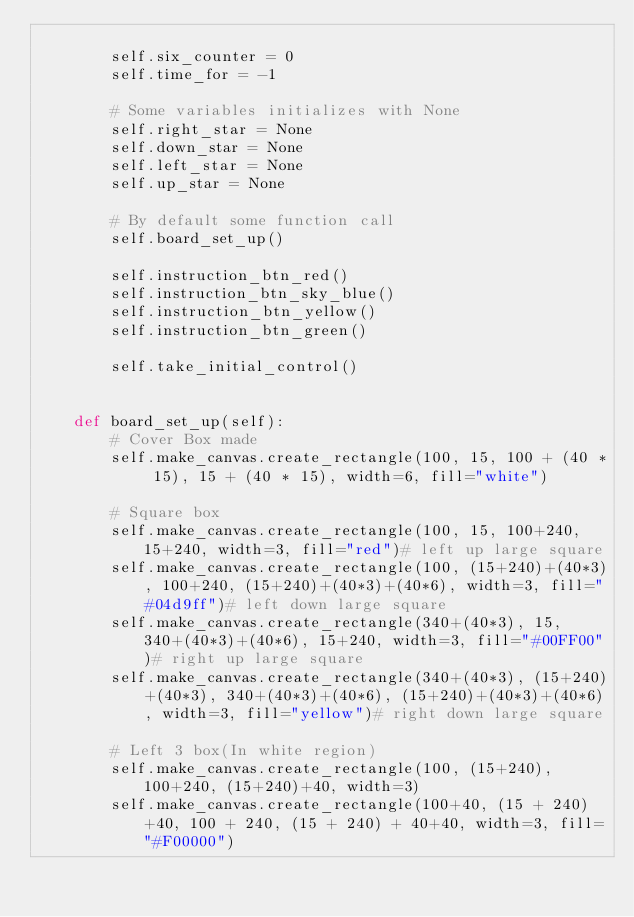Convert code to text. <code><loc_0><loc_0><loc_500><loc_500><_Python_>
        self.six_counter = 0
        self.time_for = -1

        # Some variables initializes with None
        self.right_star = None
        self.down_star = None
        self.left_star = None
        self.up_star = None

        # By default some function call
        self.board_set_up()

        self.instruction_btn_red()
        self.instruction_btn_sky_blue()
        self.instruction_btn_yellow()
        self.instruction_btn_green()

        self.take_initial_control()


    def board_set_up(self):
        # Cover Box made
        self.make_canvas.create_rectangle(100, 15, 100 + (40 * 15), 15 + (40 * 15), width=6, fill="white")

        # Square box
        self.make_canvas.create_rectangle(100, 15, 100+240, 15+240, width=3, fill="red")# left up large square
        self.make_canvas.create_rectangle(100, (15+240)+(40*3), 100+240, (15+240)+(40*3)+(40*6), width=3, fill="#04d9ff")# left down large square
        self.make_canvas.create_rectangle(340+(40*3), 15, 340+(40*3)+(40*6), 15+240, width=3, fill="#00FF00")# right up large square
        self.make_canvas.create_rectangle(340+(40*3), (15+240)+(40*3), 340+(40*3)+(40*6), (15+240)+(40*3)+(40*6), width=3, fill="yellow")# right down large square

        # Left 3 box(In white region)
        self.make_canvas.create_rectangle(100, (15+240), 100+240, (15+240)+40, width=3)
        self.make_canvas.create_rectangle(100+40, (15 + 240)+40, 100 + 240, (15 + 240) + 40+40, width=3, fill="#F00000")</code> 